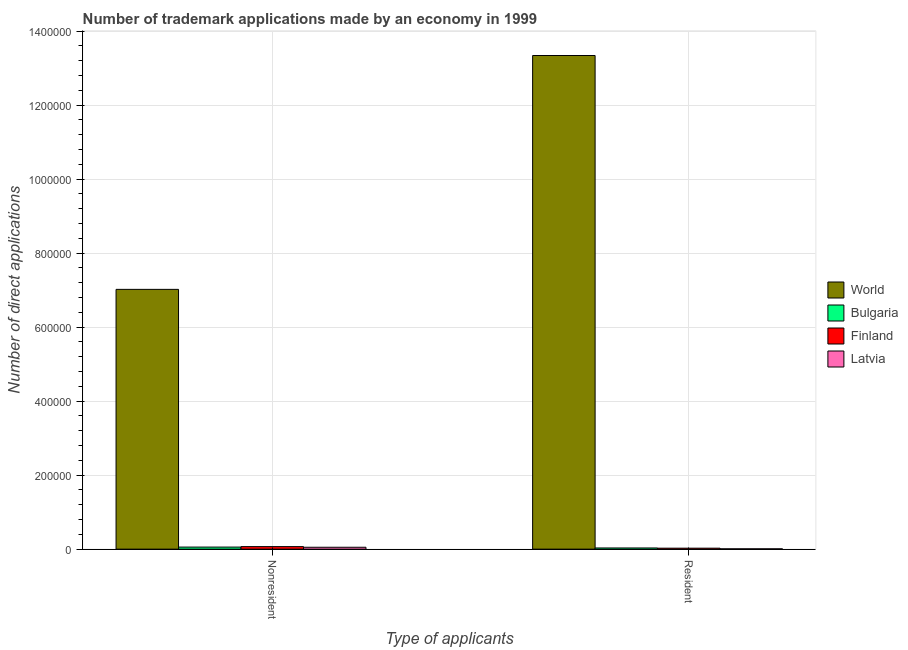How many different coloured bars are there?
Offer a terse response. 4. Are the number of bars per tick equal to the number of legend labels?
Give a very brief answer. Yes. How many bars are there on the 1st tick from the left?
Make the answer very short. 4. What is the label of the 1st group of bars from the left?
Your answer should be very brief. Nonresident. What is the number of trademark applications made by non residents in Latvia?
Offer a terse response. 5122. Across all countries, what is the maximum number of trademark applications made by residents?
Keep it short and to the point. 1.33e+06. Across all countries, what is the minimum number of trademark applications made by residents?
Give a very brief answer. 842. In which country was the number of trademark applications made by non residents maximum?
Ensure brevity in your answer.  World. In which country was the number of trademark applications made by non residents minimum?
Offer a very short reply. Latvia. What is the total number of trademark applications made by non residents in the graph?
Make the answer very short. 7.20e+05. What is the difference between the number of trademark applications made by non residents in Latvia and that in World?
Your answer should be compact. -6.97e+05. What is the difference between the number of trademark applications made by non residents in World and the number of trademark applications made by residents in Latvia?
Offer a very short reply. 7.01e+05. What is the average number of trademark applications made by non residents per country?
Provide a succinct answer. 1.80e+05. What is the difference between the number of trademark applications made by non residents and number of trademark applications made by residents in Bulgaria?
Your answer should be very brief. 2362. What is the ratio of the number of trademark applications made by non residents in Latvia to that in Finland?
Offer a very short reply. 0.75. Is the number of trademark applications made by non residents in Finland less than that in Latvia?
Provide a short and direct response. No. In how many countries, is the number of trademark applications made by residents greater than the average number of trademark applications made by residents taken over all countries?
Ensure brevity in your answer.  1. What does the 1st bar from the left in Resident represents?
Ensure brevity in your answer.  World. How many bars are there?
Your response must be concise. 8. How many countries are there in the graph?
Keep it short and to the point. 4. Does the graph contain grids?
Your answer should be very brief. Yes. Where does the legend appear in the graph?
Your response must be concise. Center right. How many legend labels are there?
Ensure brevity in your answer.  4. What is the title of the graph?
Provide a short and direct response. Number of trademark applications made by an economy in 1999. Does "Antigua and Barbuda" appear as one of the legend labels in the graph?
Give a very brief answer. No. What is the label or title of the X-axis?
Keep it short and to the point. Type of applicants. What is the label or title of the Y-axis?
Your answer should be very brief. Number of direct applications. What is the Number of direct applications in World in Nonresident?
Ensure brevity in your answer.  7.02e+05. What is the Number of direct applications in Bulgaria in Nonresident?
Provide a succinct answer. 5572. What is the Number of direct applications of Finland in Nonresident?
Your answer should be compact. 6851. What is the Number of direct applications in Latvia in Nonresident?
Provide a short and direct response. 5122. What is the Number of direct applications in World in Resident?
Provide a succinct answer. 1.33e+06. What is the Number of direct applications in Bulgaria in Resident?
Make the answer very short. 3210. What is the Number of direct applications in Finland in Resident?
Give a very brief answer. 2620. What is the Number of direct applications of Latvia in Resident?
Ensure brevity in your answer.  842. Across all Type of applicants, what is the maximum Number of direct applications in World?
Offer a very short reply. 1.33e+06. Across all Type of applicants, what is the maximum Number of direct applications of Bulgaria?
Provide a succinct answer. 5572. Across all Type of applicants, what is the maximum Number of direct applications of Finland?
Provide a short and direct response. 6851. Across all Type of applicants, what is the maximum Number of direct applications in Latvia?
Provide a short and direct response. 5122. Across all Type of applicants, what is the minimum Number of direct applications in World?
Your response must be concise. 7.02e+05. Across all Type of applicants, what is the minimum Number of direct applications in Bulgaria?
Your response must be concise. 3210. Across all Type of applicants, what is the minimum Number of direct applications in Finland?
Your response must be concise. 2620. Across all Type of applicants, what is the minimum Number of direct applications in Latvia?
Your answer should be compact. 842. What is the total Number of direct applications in World in the graph?
Offer a terse response. 2.04e+06. What is the total Number of direct applications of Bulgaria in the graph?
Provide a short and direct response. 8782. What is the total Number of direct applications in Finland in the graph?
Give a very brief answer. 9471. What is the total Number of direct applications of Latvia in the graph?
Your answer should be compact. 5964. What is the difference between the Number of direct applications in World in Nonresident and that in Resident?
Provide a short and direct response. -6.32e+05. What is the difference between the Number of direct applications in Bulgaria in Nonresident and that in Resident?
Offer a very short reply. 2362. What is the difference between the Number of direct applications of Finland in Nonresident and that in Resident?
Your response must be concise. 4231. What is the difference between the Number of direct applications of Latvia in Nonresident and that in Resident?
Make the answer very short. 4280. What is the difference between the Number of direct applications in World in Nonresident and the Number of direct applications in Bulgaria in Resident?
Provide a short and direct response. 6.99e+05. What is the difference between the Number of direct applications of World in Nonresident and the Number of direct applications of Finland in Resident?
Keep it short and to the point. 6.99e+05. What is the difference between the Number of direct applications in World in Nonresident and the Number of direct applications in Latvia in Resident?
Keep it short and to the point. 7.01e+05. What is the difference between the Number of direct applications in Bulgaria in Nonresident and the Number of direct applications in Finland in Resident?
Your answer should be very brief. 2952. What is the difference between the Number of direct applications in Bulgaria in Nonresident and the Number of direct applications in Latvia in Resident?
Ensure brevity in your answer.  4730. What is the difference between the Number of direct applications in Finland in Nonresident and the Number of direct applications in Latvia in Resident?
Provide a succinct answer. 6009. What is the average Number of direct applications in World per Type of applicants?
Your answer should be compact. 1.02e+06. What is the average Number of direct applications in Bulgaria per Type of applicants?
Provide a succinct answer. 4391. What is the average Number of direct applications of Finland per Type of applicants?
Provide a succinct answer. 4735.5. What is the average Number of direct applications in Latvia per Type of applicants?
Keep it short and to the point. 2982. What is the difference between the Number of direct applications in World and Number of direct applications in Bulgaria in Nonresident?
Make the answer very short. 6.97e+05. What is the difference between the Number of direct applications of World and Number of direct applications of Finland in Nonresident?
Your answer should be very brief. 6.95e+05. What is the difference between the Number of direct applications of World and Number of direct applications of Latvia in Nonresident?
Make the answer very short. 6.97e+05. What is the difference between the Number of direct applications in Bulgaria and Number of direct applications in Finland in Nonresident?
Provide a succinct answer. -1279. What is the difference between the Number of direct applications of Bulgaria and Number of direct applications of Latvia in Nonresident?
Offer a terse response. 450. What is the difference between the Number of direct applications in Finland and Number of direct applications in Latvia in Nonresident?
Keep it short and to the point. 1729. What is the difference between the Number of direct applications of World and Number of direct applications of Bulgaria in Resident?
Your response must be concise. 1.33e+06. What is the difference between the Number of direct applications of World and Number of direct applications of Finland in Resident?
Give a very brief answer. 1.33e+06. What is the difference between the Number of direct applications in World and Number of direct applications in Latvia in Resident?
Offer a very short reply. 1.33e+06. What is the difference between the Number of direct applications in Bulgaria and Number of direct applications in Finland in Resident?
Keep it short and to the point. 590. What is the difference between the Number of direct applications in Bulgaria and Number of direct applications in Latvia in Resident?
Offer a terse response. 2368. What is the difference between the Number of direct applications of Finland and Number of direct applications of Latvia in Resident?
Your answer should be compact. 1778. What is the ratio of the Number of direct applications of World in Nonresident to that in Resident?
Offer a very short reply. 0.53. What is the ratio of the Number of direct applications of Bulgaria in Nonresident to that in Resident?
Make the answer very short. 1.74. What is the ratio of the Number of direct applications of Finland in Nonresident to that in Resident?
Offer a terse response. 2.61. What is the ratio of the Number of direct applications of Latvia in Nonresident to that in Resident?
Provide a short and direct response. 6.08. What is the difference between the highest and the second highest Number of direct applications in World?
Offer a terse response. 6.32e+05. What is the difference between the highest and the second highest Number of direct applications in Bulgaria?
Your response must be concise. 2362. What is the difference between the highest and the second highest Number of direct applications of Finland?
Provide a succinct answer. 4231. What is the difference between the highest and the second highest Number of direct applications in Latvia?
Your response must be concise. 4280. What is the difference between the highest and the lowest Number of direct applications of World?
Your answer should be very brief. 6.32e+05. What is the difference between the highest and the lowest Number of direct applications in Bulgaria?
Make the answer very short. 2362. What is the difference between the highest and the lowest Number of direct applications in Finland?
Offer a terse response. 4231. What is the difference between the highest and the lowest Number of direct applications of Latvia?
Offer a terse response. 4280. 